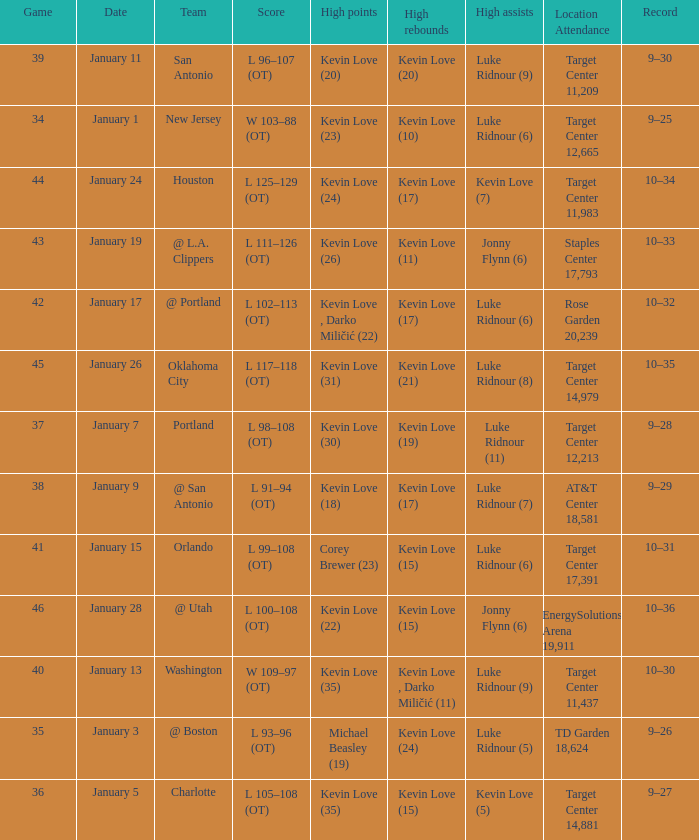In how many instances did kevin love (22) have the most points? 1.0. 